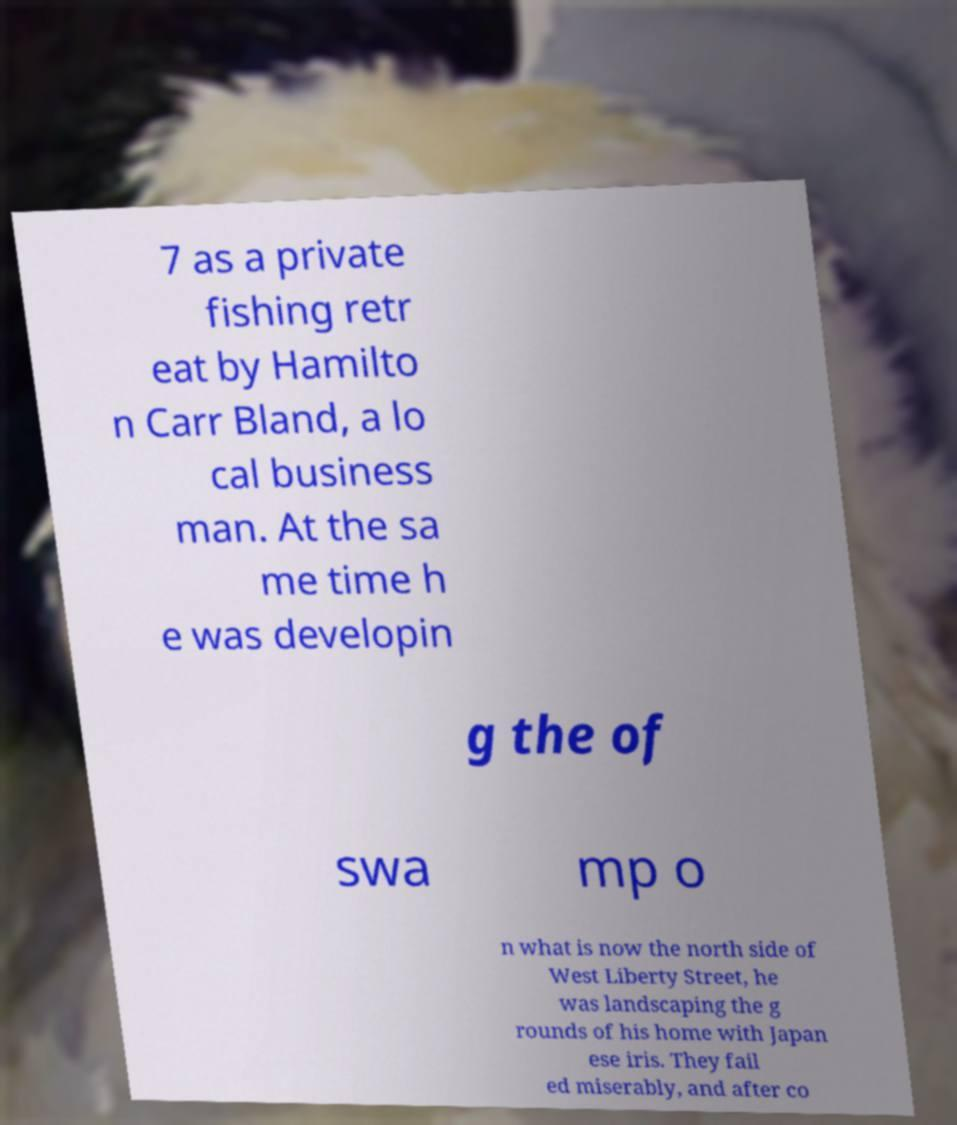What messages or text are displayed in this image? I need them in a readable, typed format. 7 as a private fishing retr eat by Hamilto n Carr Bland, a lo cal business man. At the sa me time h e was developin g the of swa mp o n what is now the north side of West Liberty Street, he was landscaping the g rounds of his home with Japan ese iris. They fail ed miserably, and after co 